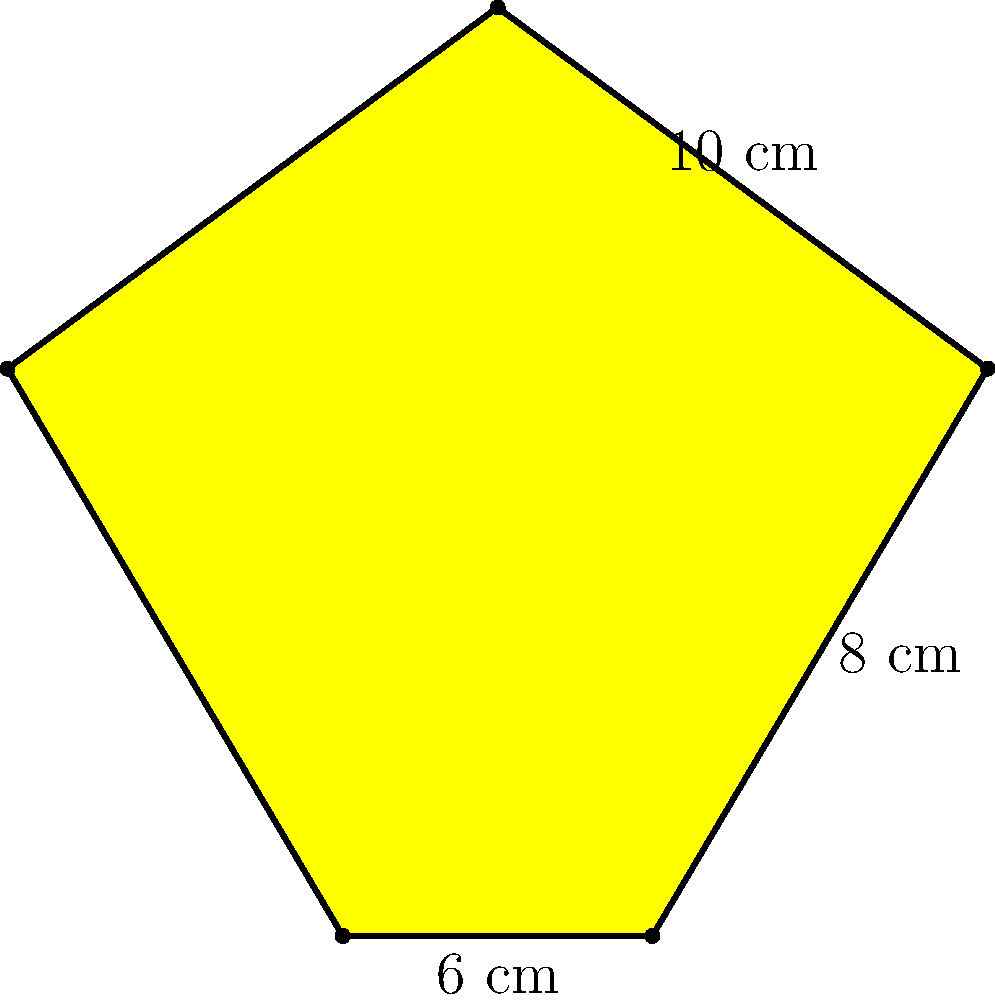A star-shaped award plaque is given to successful musicians who achieve platinum status. The plaque has 5 identical points, with the distances between consecutive points shown in the diagram. What is the perimeter of this award plaque? Let's approach this step-by-step:

1) The star has 5 identical points, which means all sides are equal in length.

2) We are given three measurements:
   - 10 cm between two upper points
   - 8 cm from an upper point to a lower point
   - 6 cm between two lower points

3) To find the perimeter, we need to add up the lengths of all sides.

4) There are 5 sides in total, each consisting of two segments:
   - One segment of 8 cm (from an upper point to a lower point)
   - One segment that's half of either 10 cm or 6 cm (depending on whether it's an upper or lower segment)

5) For the upper segments: $\frac{10}{2} = 5$ cm
   For the lower segments: $\frac{6}{2} = 3$ cm

6) So each side of the star is:
   Upper side: $8 + 5 = 13$ cm
   Lower side: $8 + 3 = 11$ cm

7) Since there are 5 identical sides, and each side is 13 cm + 11 cm = 24 cm, we can calculate the perimeter:

   Perimeter = $5 \times 24 = 120$ cm

Therefore, the perimeter of the star-shaped award plaque is 120 cm.
Answer: 120 cm 